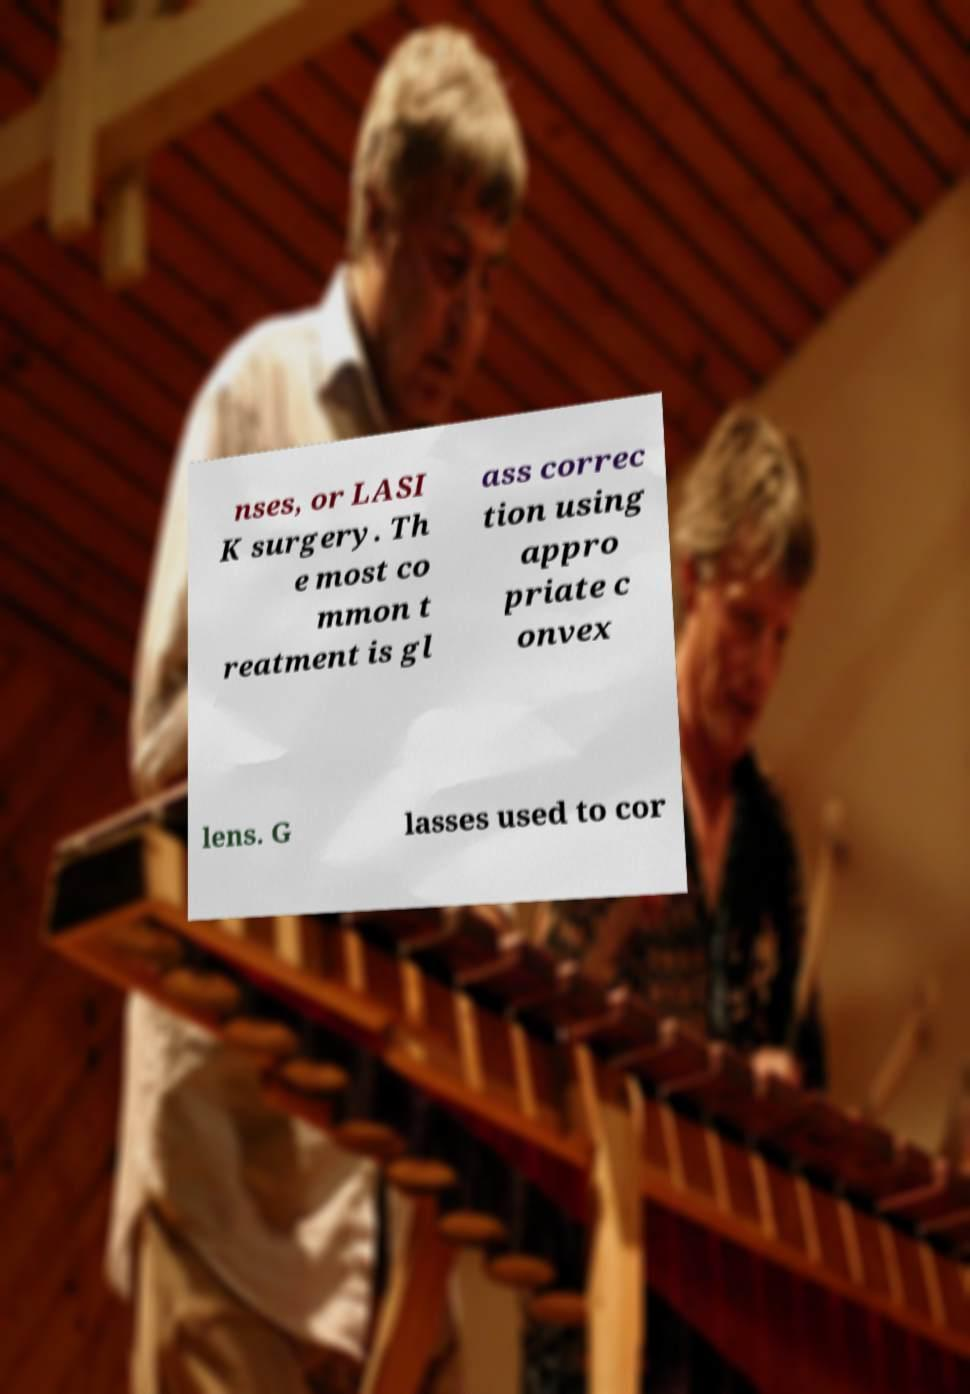Could you assist in decoding the text presented in this image and type it out clearly? nses, or LASI K surgery. Th e most co mmon t reatment is gl ass correc tion using appro priate c onvex lens. G lasses used to cor 